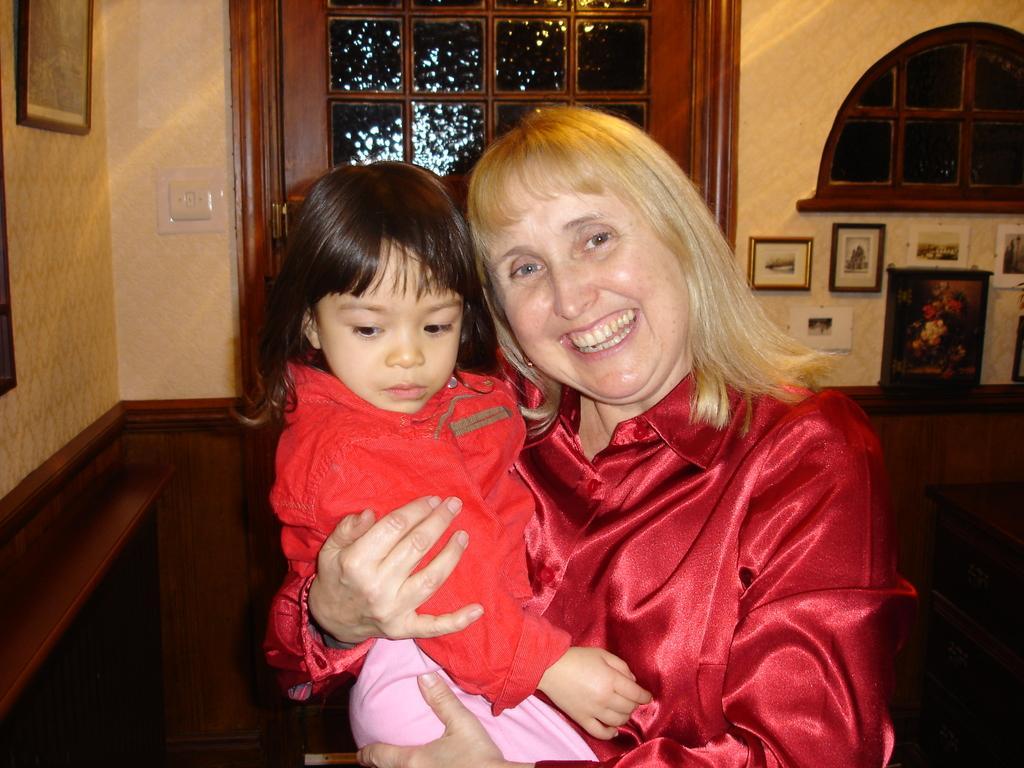Describe this image in one or two sentences. In a given image i can see a people,door,window,photo frames and switches. 